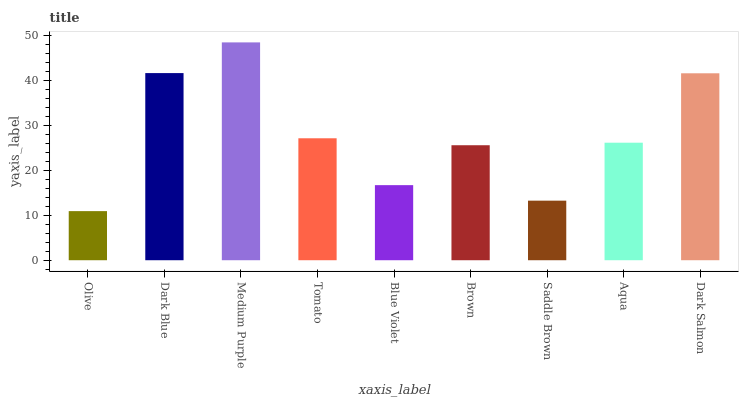Is Olive the minimum?
Answer yes or no. Yes. Is Medium Purple the maximum?
Answer yes or no. Yes. Is Dark Blue the minimum?
Answer yes or no. No. Is Dark Blue the maximum?
Answer yes or no. No. Is Dark Blue greater than Olive?
Answer yes or no. Yes. Is Olive less than Dark Blue?
Answer yes or no. Yes. Is Olive greater than Dark Blue?
Answer yes or no. No. Is Dark Blue less than Olive?
Answer yes or no. No. Is Aqua the high median?
Answer yes or no. Yes. Is Aqua the low median?
Answer yes or no. Yes. Is Saddle Brown the high median?
Answer yes or no. No. Is Medium Purple the low median?
Answer yes or no. No. 